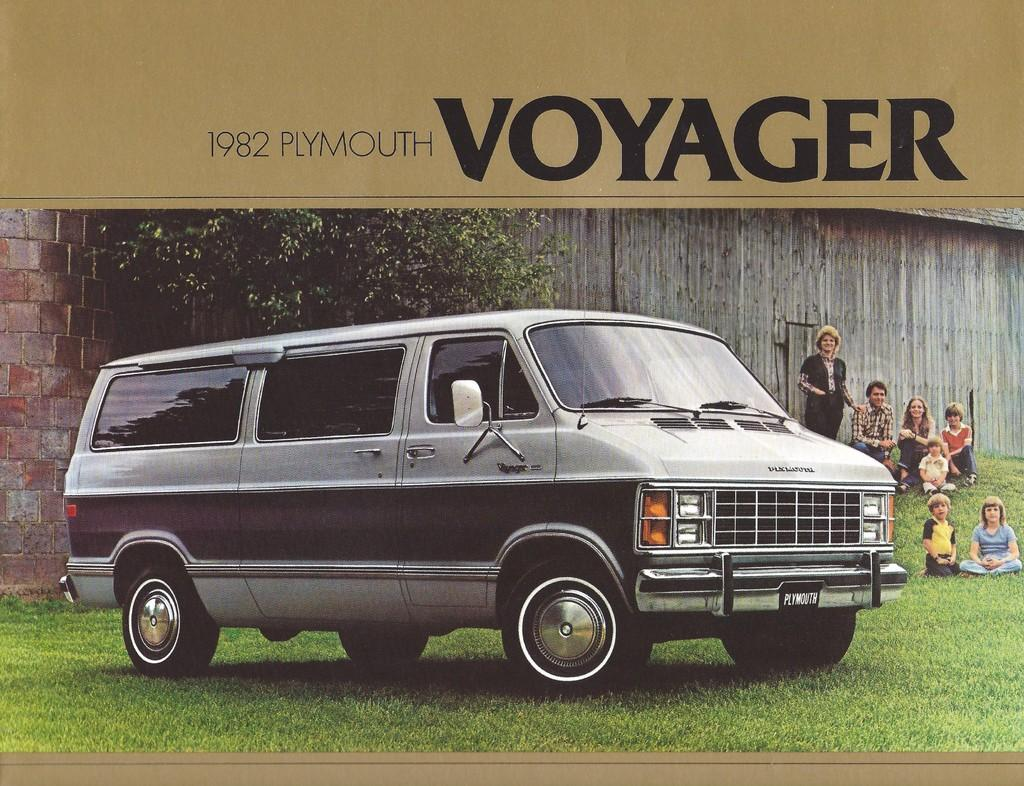What type of vehicle is on the ground in the image? There is a van on the ground in the image. Who or what can be seen in the image besides the van? There are people in the image. What type of natural environment is visible in the image? Grass is present in the image. What type of plant is visible in the image? There is a tree in the image. What type of structure is visible in the image? There is a wall in the image. What else can be seen in the image besides the van, people, grass, tree, and wall? There is some text visible in the image. What is the condition of the aunt's house in the image? There is no mention of an aunt or a house in the image, so we cannot determine the condition of the aunt's house. 